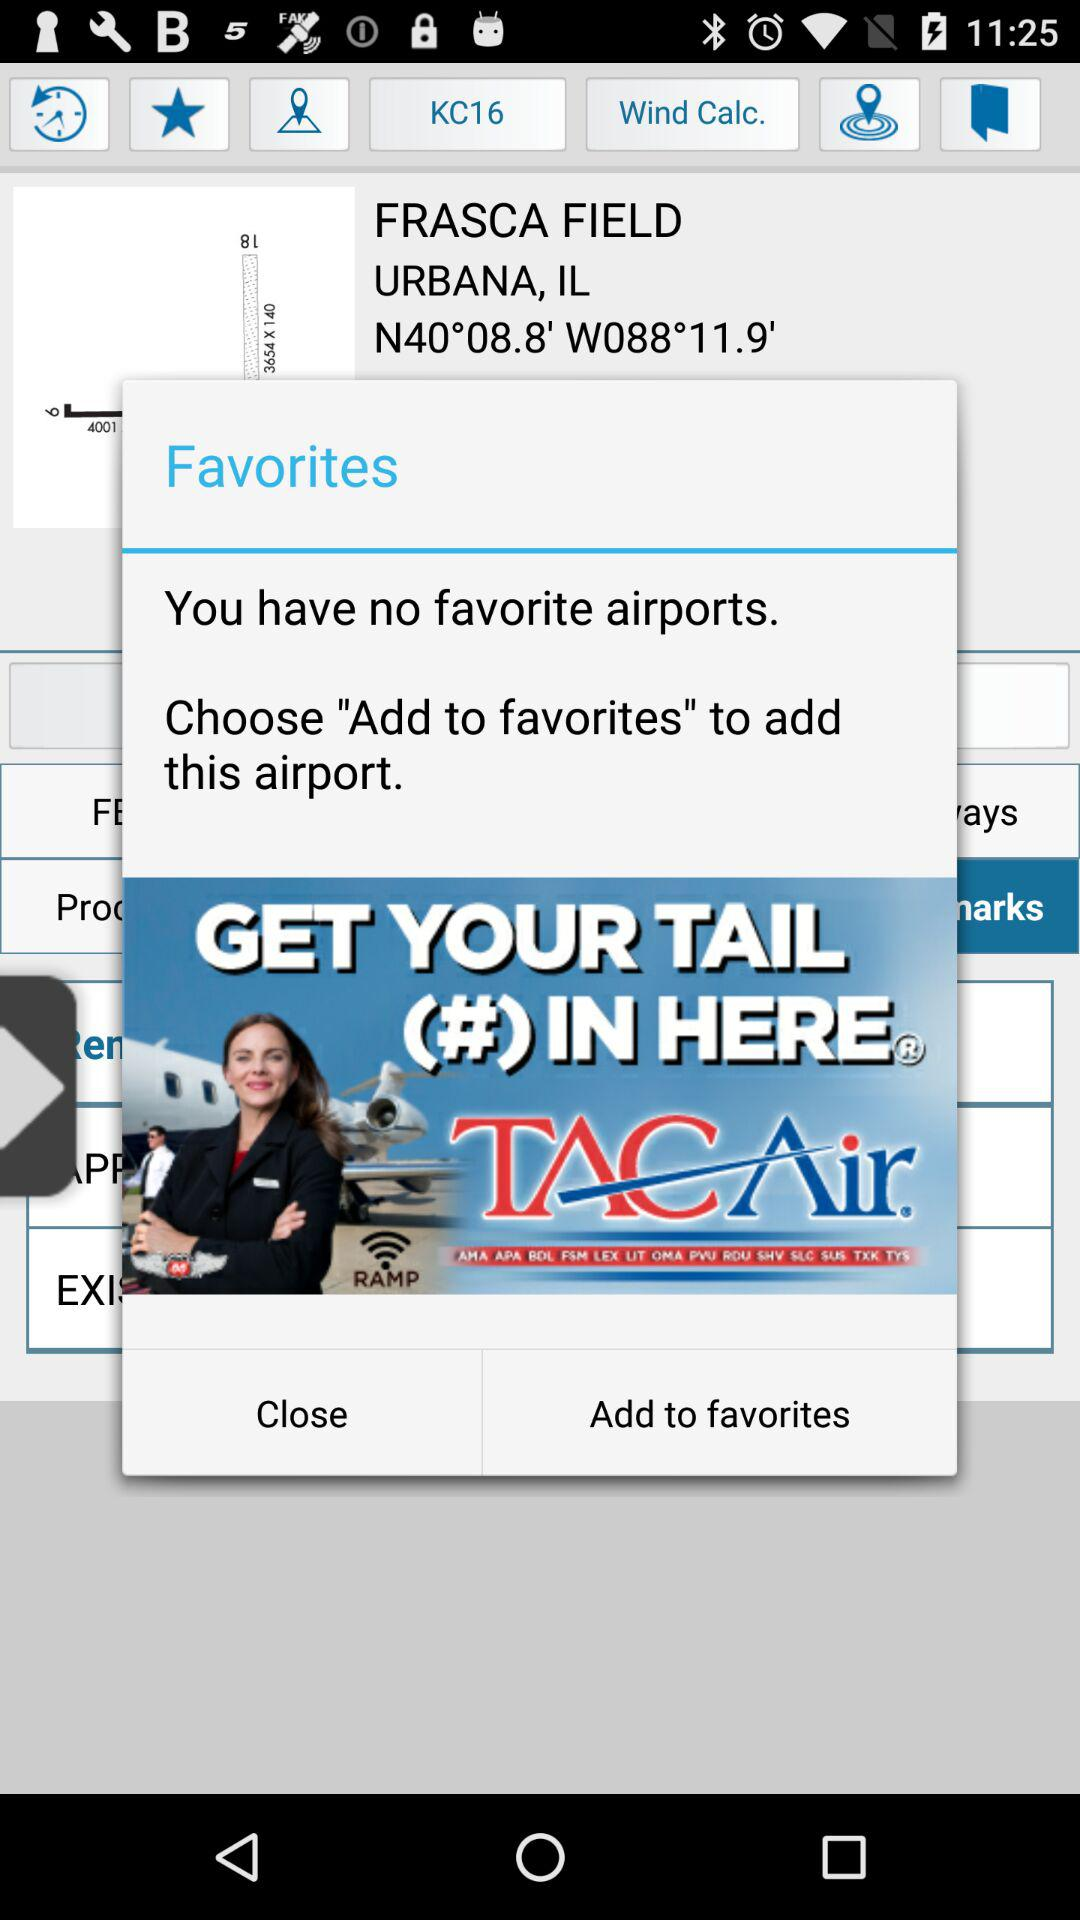What is the given address? The given address is Frasca Field Urbana, IL N40°08.8' W088°11.9'. 